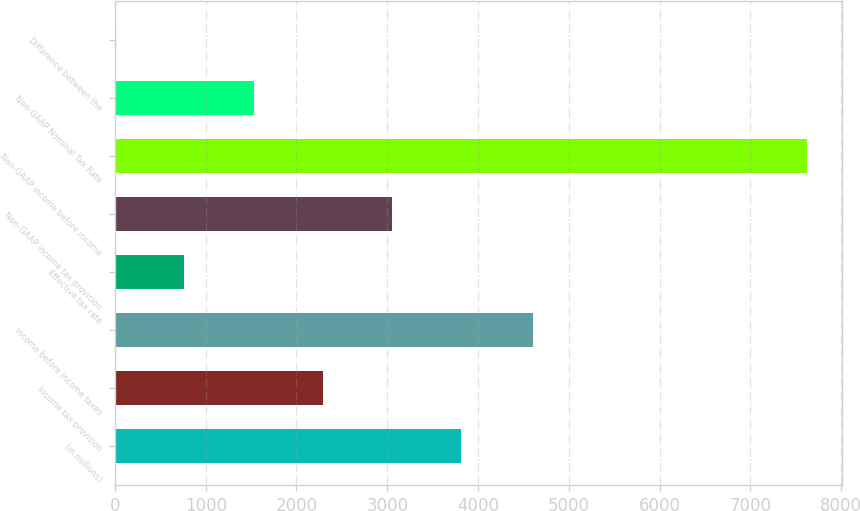Convert chart to OTSL. <chart><loc_0><loc_0><loc_500><loc_500><bar_chart><fcel>(in millions)<fcel>Income tax provision<fcel>Income before income taxes<fcel>Effective tax rate<fcel>Non-GAAP income tax provision<fcel>Non-GAAP income before income<fcel>Non-GAAP Nominal Tax Rate<fcel>Difference between the<nl><fcel>3813.3<fcel>2289.42<fcel>4602<fcel>765.54<fcel>3051.36<fcel>7623<fcel>1527.48<fcel>3.6<nl></chart> 